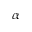Convert formula to latex. <formula><loc_0><loc_0><loc_500><loc_500>\alpha</formula> 